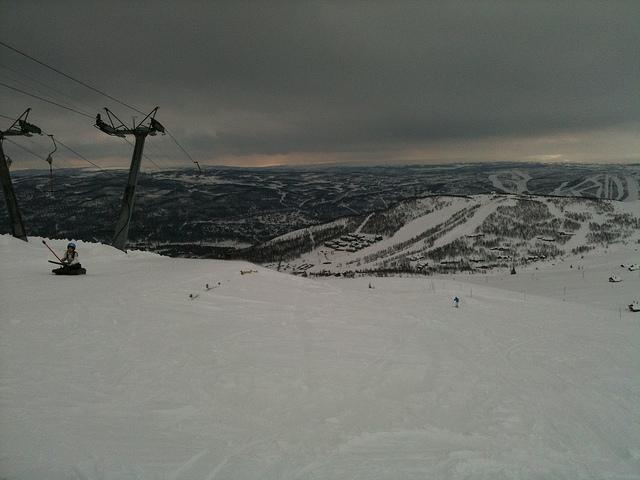What are the overhead cables for?

Choices:
A) guiding skiers
B) carry electricity
C) decorative only
D) carry skiers carry skiers 